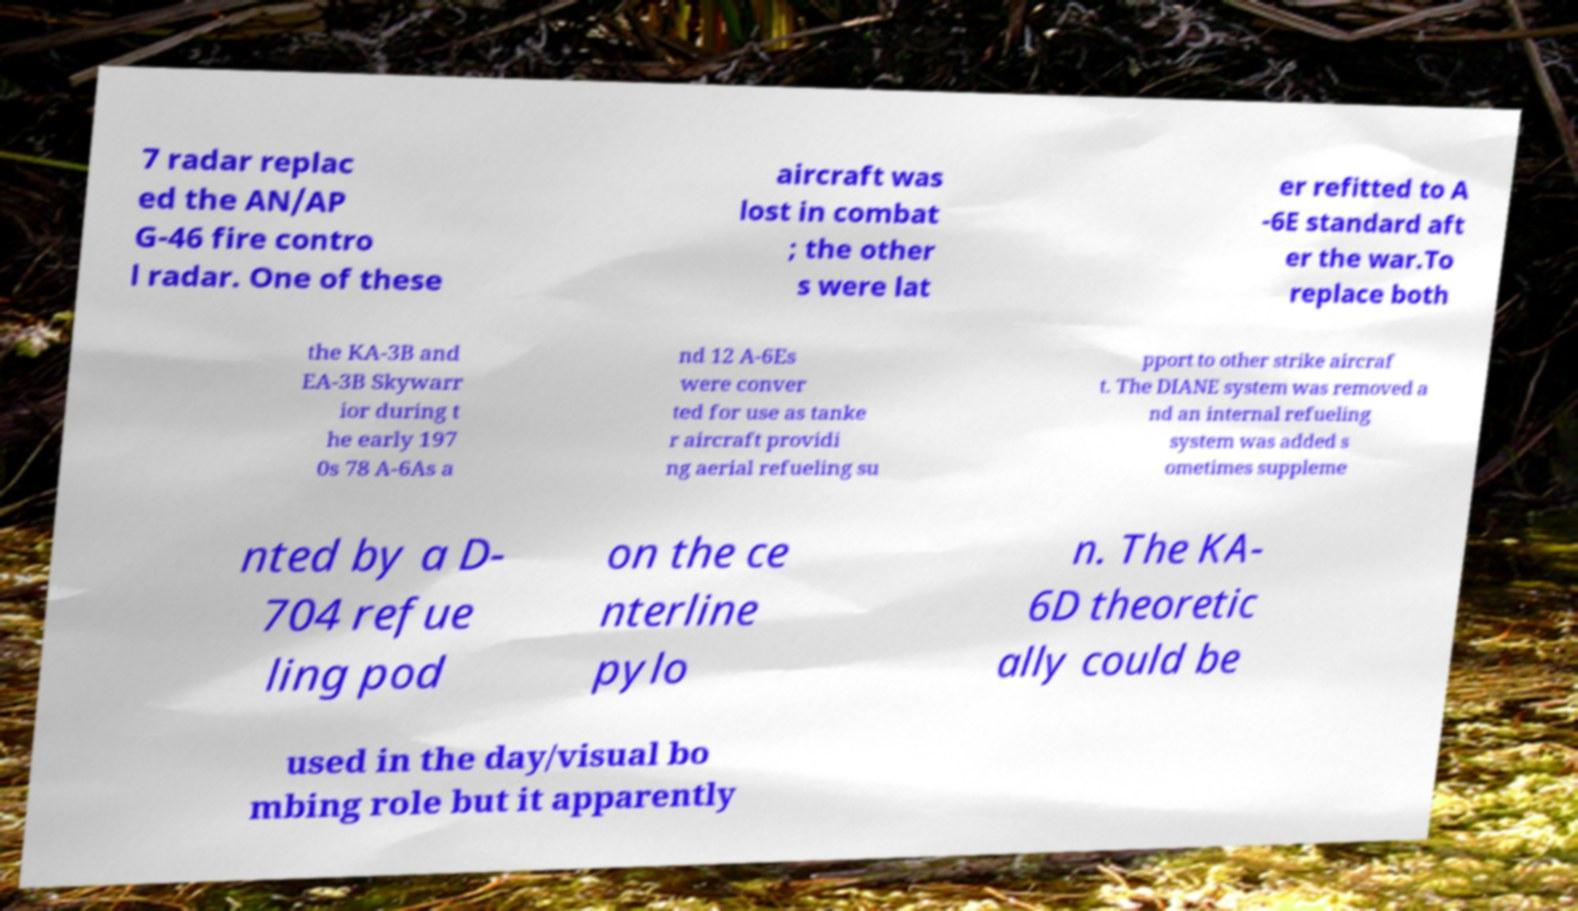Could you extract and type out the text from this image? 7 radar replac ed the AN/AP G-46 fire contro l radar. One of these aircraft was lost in combat ; the other s were lat er refitted to A -6E standard aft er the war.To replace both the KA-3B and EA-3B Skywarr ior during t he early 197 0s 78 A-6As a nd 12 A-6Es were conver ted for use as tanke r aircraft providi ng aerial refueling su pport to other strike aircraf t. The DIANE system was removed a nd an internal refueling system was added s ometimes suppleme nted by a D- 704 refue ling pod on the ce nterline pylo n. The KA- 6D theoretic ally could be used in the day/visual bo mbing role but it apparently 